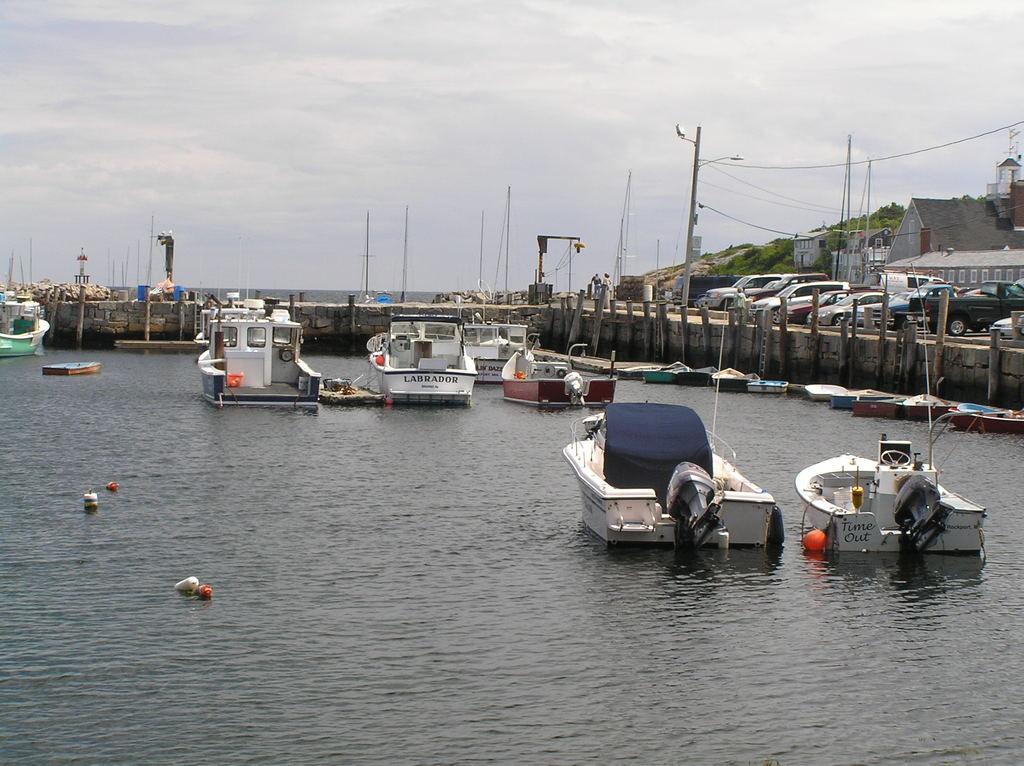Please provide a concise description of this image. In this image at the bottom there is a river, and in that river there are some ships. And in the background there is a wall, poles, vehicles, trees and some buildings. And at the top there is sky. 